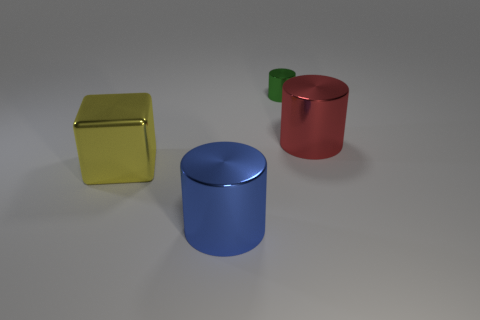How many small red cylinders have the same material as the big cube?
Provide a succinct answer. 0. Does the shiny thing on the left side of the blue object have the same size as the tiny cylinder?
Keep it short and to the point. No. There is a big cube that is made of the same material as the green cylinder; what is its color?
Make the answer very short. Yellow. Is there any other thing that is the same size as the shiny block?
Ensure brevity in your answer.  Yes. How many large yellow shiny blocks are on the left side of the yellow shiny block?
Your response must be concise. 0. Do the large metal cylinder to the right of the blue object and the big cylinder on the left side of the small cylinder have the same color?
Keep it short and to the point. No. What color is the other tiny metallic thing that is the same shape as the blue thing?
Your response must be concise. Green. Is there anything else that is the same shape as the small metal object?
Your response must be concise. Yes. Do the large metallic thing in front of the big yellow cube and the object that is left of the blue shiny cylinder have the same shape?
Your answer should be compact. No. There is a yellow cube; does it have the same size as the object in front of the large shiny block?
Offer a terse response. Yes. 